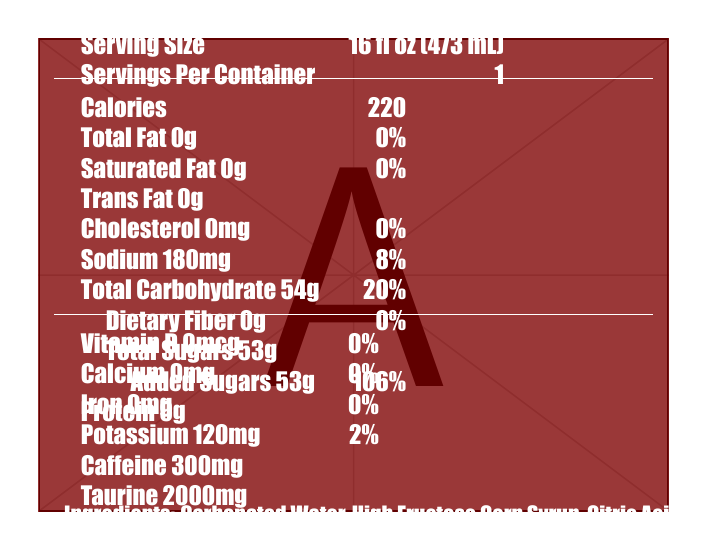what is the serving size of Hellfire Surge: Blood Red Edition? The serving size is listed as "16 fl oz (473 mL)" in the Nutrition Facts section.
Answer: 16 fl oz (473 mL) how many calories are in a single serving? The document specifies that there are 220 calories per serving.
Answer: 220 what is the total carbohydrate content per serving? The total carbohydrate content is listed as "54g" in the Nutrition Facts.
Answer: 54g how much caffeine is in Hellfire Surge: Blood Red Edition? The caffeine content is listed as "300mg" in the Nutrition Facts.
Answer: 300mg what are the added sugars in the drink? The document mentions "Added Sugars: 53g" in the Nutrition Facts.
Answer: 53g how much sodium does the drink contain? The sodium content is listed as "180mg" in the Nutrition Facts.
Answer: 180mg does the drink contain any dietary fiber? The document lists "Dietary Fiber: 0g," indicating there is no dietary fiber in the drink.
Answer: No which vitamins are included in the drink? A. Vitamin C B. Vitamin B3 C. Vitamin B6 D. Vitamin B12 The document lists three B vitamins: Vitamin B3 (40mg), Vitamin B6 (4mg), and Vitamin B12 (12mcg).
Answer: B, C, D what is the percentage of daily value for added sugars? A. 53% B. 88% C. 68% D. 106% The document lists "Added Sugars 53g" with a daily value of "106%".
Answer: D. 106% is this drink recommended for children? The warning states that the drink is "Not recommended for children."
Answer: No describe the entire document briefly The description covers the key elements: the product name, major nutritional facts, cautionary details, and design aspects of the document.
Answer: The document is a nutrition label for "Hellfire Surge: Blood Red Edition," an energy drink with high caffeine content. It includes nutritional information, ingredients, a warning, and promotional text. The drink contains 220 calories, 300mg of caffeine, and a significant amount of added sugars. The label is visually designed with dark and red metal aesthetics. what is the total fat content per serving? The document lists the total fat content as "0g."
Answer: 0g how much potassium does the drink contain? The potassium content is listed as "120mg" in the Nutrition Facts.
Answer: 120mg how is the product visually advertised? The promotional text at the bottom of the document contains this message.
Answer: Fuel your darkest performances with the blood of the metal gods. Hellfire Surge: Blood Red Edition - Unleash the beast within! are there any artificial flavors in the drink? The ingredients list includes "Natural and Artificial Flavors."
Answer: Yes what is the drink's main color additive? The ingredients list mentions "Beet Juice Concentrate (for color)."
Answer: Beet Juice Concentrate what is the specific amount of taurine in the drink? The document lists taurine content as "2000mg."
Answer: 2000mg how many servings are in one container? The document specifies that there is "1" serving per container.
Answer: 1 how does the design of the document reflect the drink’s branding? The document design includes a bloodred background, dark metal aesthetics, and bold fonts that align with the heavy metal scene and the drink's theme.
Answer: The document uses dark and red colors and impactful typeface to reflect the drink's edgy, metal-themed branding. What is the caffeine content in other energy drinks? The document only provides caffeine content for "Hellfire Surge: Blood Red Edition" and does not provide information on other energy drinks.
Answer: Not enough information 